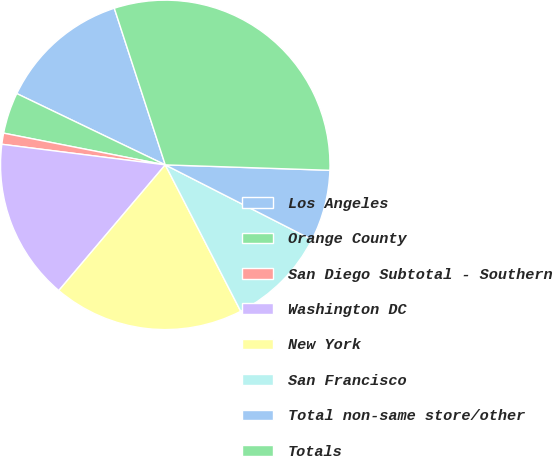<chart> <loc_0><loc_0><loc_500><loc_500><pie_chart><fcel>Los Angeles<fcel>Orange County<fcel>San Diego Subtotal - Southern<fcel>Washington DC<fcel>New York<fcel>San Francisco<fcel>Total non-same store/other<fcel>Totals<nl><fcel>12.87%<fcel>4.04%<fcel>1.09%<fcel>15.81%<fcel>18.76%<fcel>9.92%<fcel>6.98%<fcel>30.53%<nl></chart> 